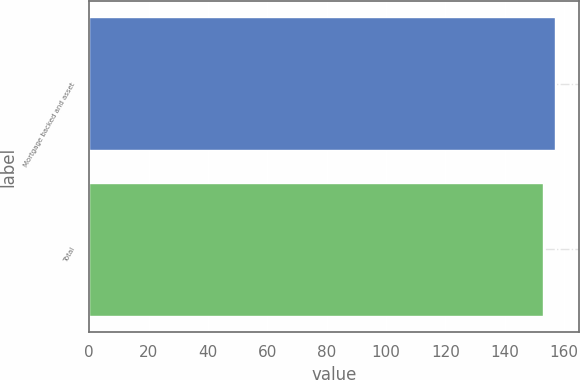Convert chart to OTSL. <chart><loc_0><loc_0><loc_500><loc_500><bar_chart><fcel>Mortgage backed and asset<fcel>Total<nl><fcel>157<fcel>153<nl></chart> 